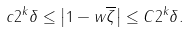<formula> <loc_0><loc_0><loc_500><loc_500>c 2 ^ { k } \delta \leq \left | 1 - w \overline { \zeta } \right | \leq C 2 ^ { k } \delta .</formula> 